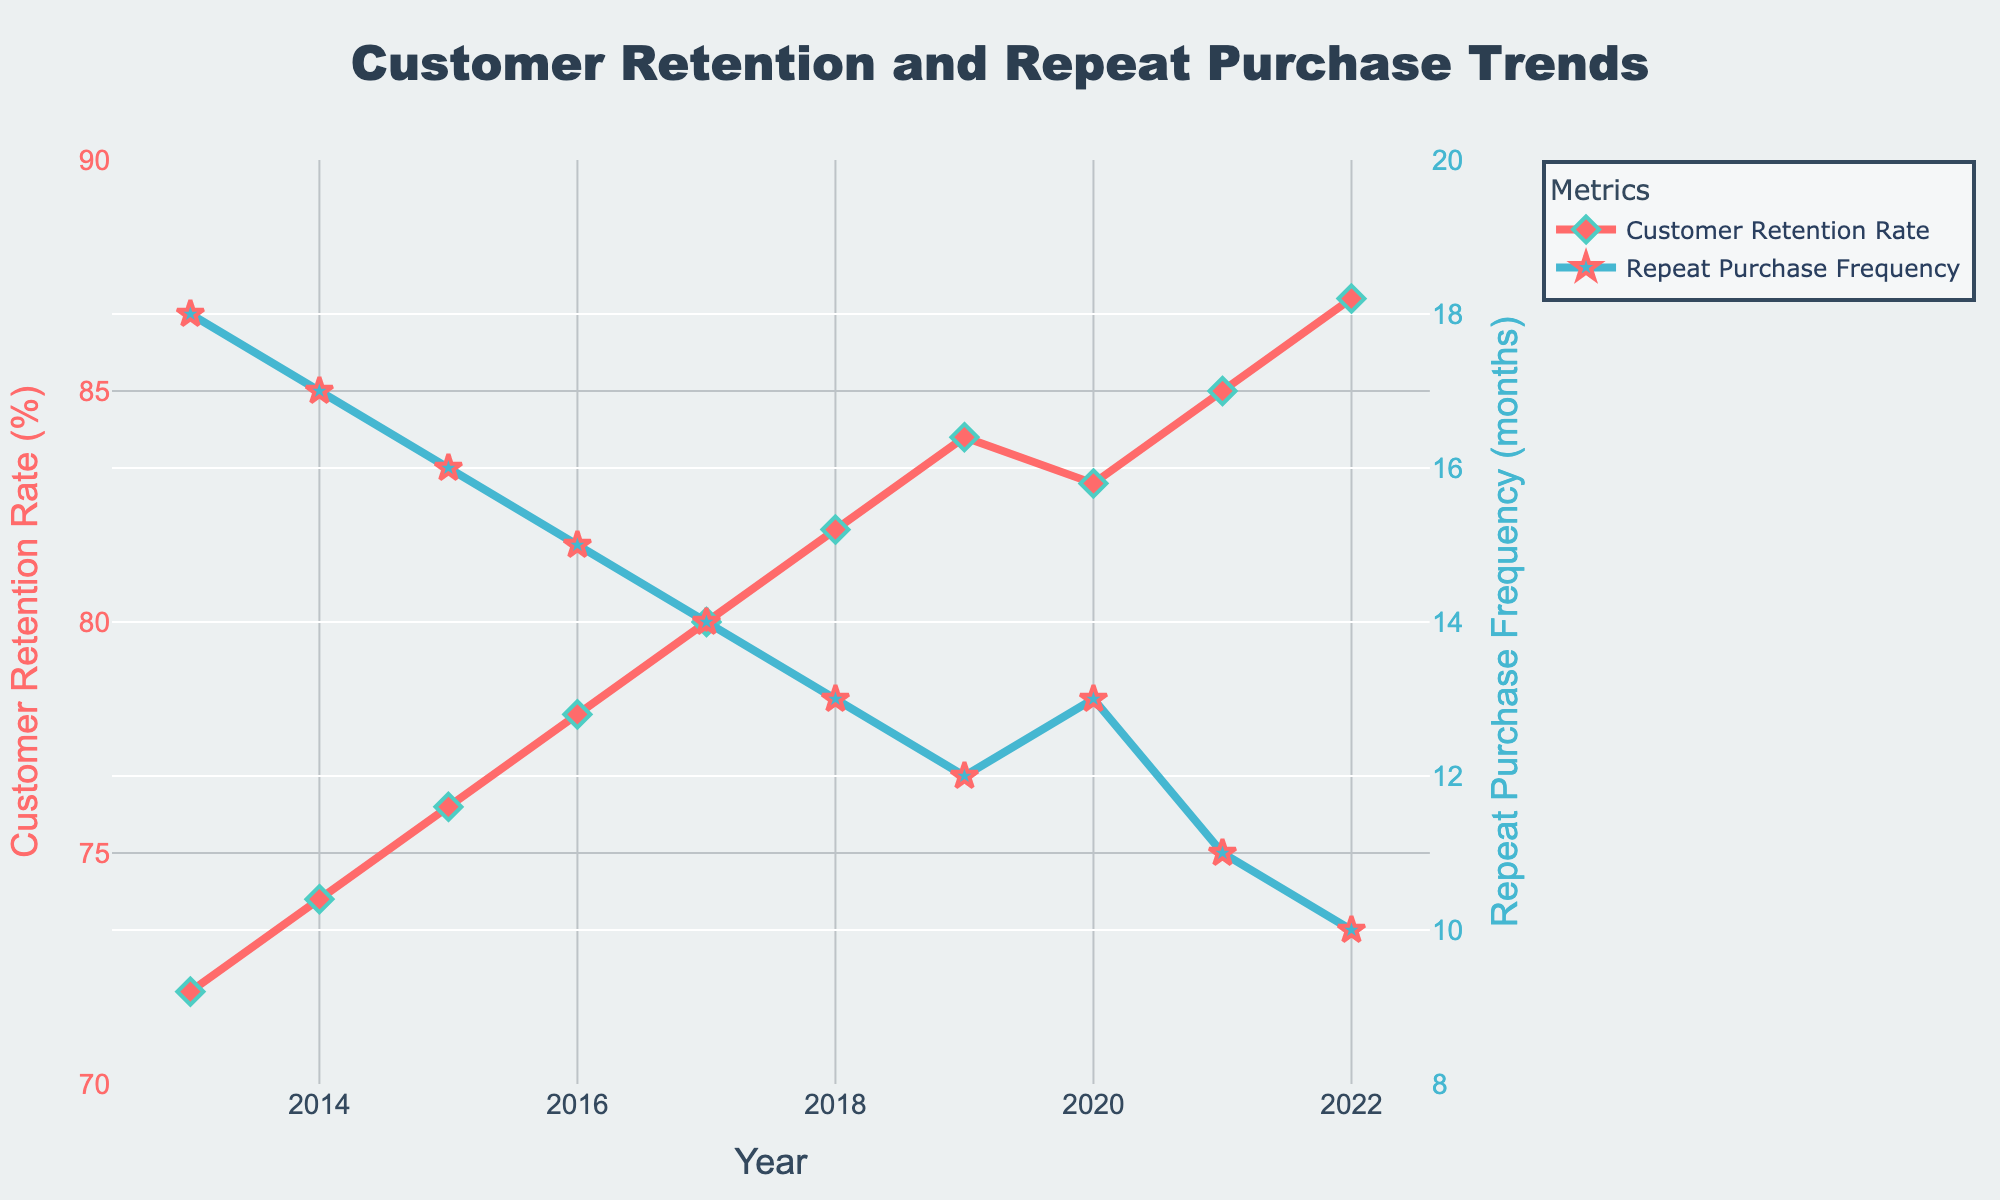What trend do you observe regarding the Customer Retention Rate (%) over the years? The Customer Retention Rate (%) shows a steady increase from 72% in 2013 to 87% in 2022, indicating improvement.
Answer: It increases Which year experienced the highest Customer Retention Rate (%)? According to the data, the year 2022 had the highest Customer Retention Rate, reaching 87%.
Answer: 2022 How does the Repeat Purchase Frequency (months) trend change over the observed period? The Repeat Purchase Frequency (months) consistently decreases over the years, starting from 18 months in 2013 to 10 months in 2022, indicating customers are purchasing more frequently.
Answer: It decreases Compare the frequency of repeat purchases in 2020 and 2022. What difference do you observe? In 2020, the Repeat Purchase Frequency was 13 months, whereas in 2022, it was 10 months. This shows that in 2022, customers made repeat purchases 3 months more frequently than in 2020.
Answer: 3 months more frequently Which metric uses a blue color in the plot? The Repeat Purchase Frequency (months) metric is represented using a blue color in the plot.
Answer: Repeat Purchase Frequency What is the difference in Customer Retention Rate (%) between the years 2013 and 2022? The Customer Retention Rate (%) in 2013 was 72%, and in 2022 it was 87%. The difference is 87% - 72% = 15%.
Answer: 15% What happens to the Customer Retention Rate (%) from 2019 to 2020? The Customer Retention Rate (%) decreases slightly from 84% in 2019 to 83% in 2020.
Answer: It decreases Between which years did the Repeat Purchase Frequency (months) remain the same? The Repeat Purchase Frequency (months) remained the same between 2019 and 2020, both being 13 months.
Answer: 2019 and 2020 What is the average Customer Retention Rate (%) from 2013 to 2022? First, sum up the Customer Retention Rates from 2013 to 2022: 72 + 74 + 76 + 78 + 80 + 82 + 84 + 83 + 85 + 87 = 801. Then, divide by the number of years, which is 10. The average is 801 / 10 = 80.1%.
Answer: 80.1% In which year was the Repeat Purchase Frequency (months) the highest? The Repeat Purchase Frequency (months) was highest in 2013, at 18 months.
Answer: 2013 